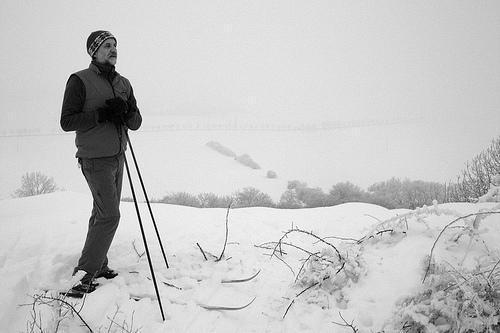How many people are shown?
Give a very brief answer. 1. 